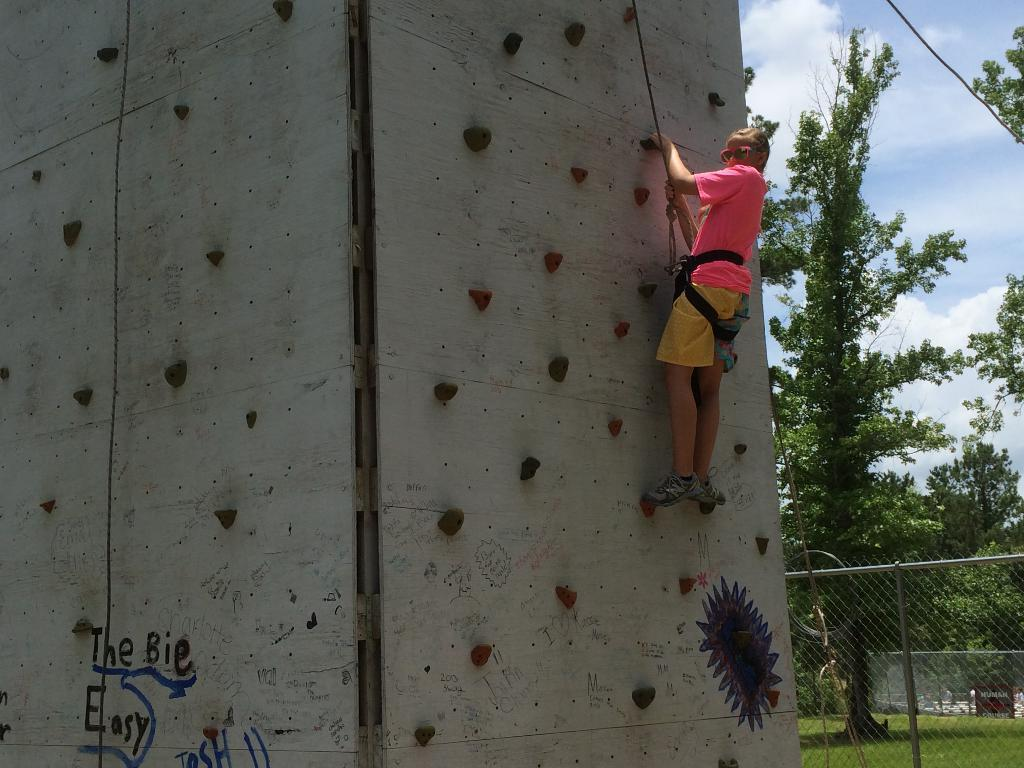What structure can be seen in the image? There is a wall in the image. What is the person in the image doing? The person is holding a rope and climbing the wall. What other barrier is present in the image? There is a fence in the image. What type of vegetation is visible in the image? Grass is present in the image, and trees are visible as well. What part of the natural environment is visible in the image? The sky is visible in the image. What verse is being recited by the brain in the image? There is no brain or verse present in the image; it features a person climbing a wall with a rope. Is there a kite visible in the image? No, there is no kite present in the image. 